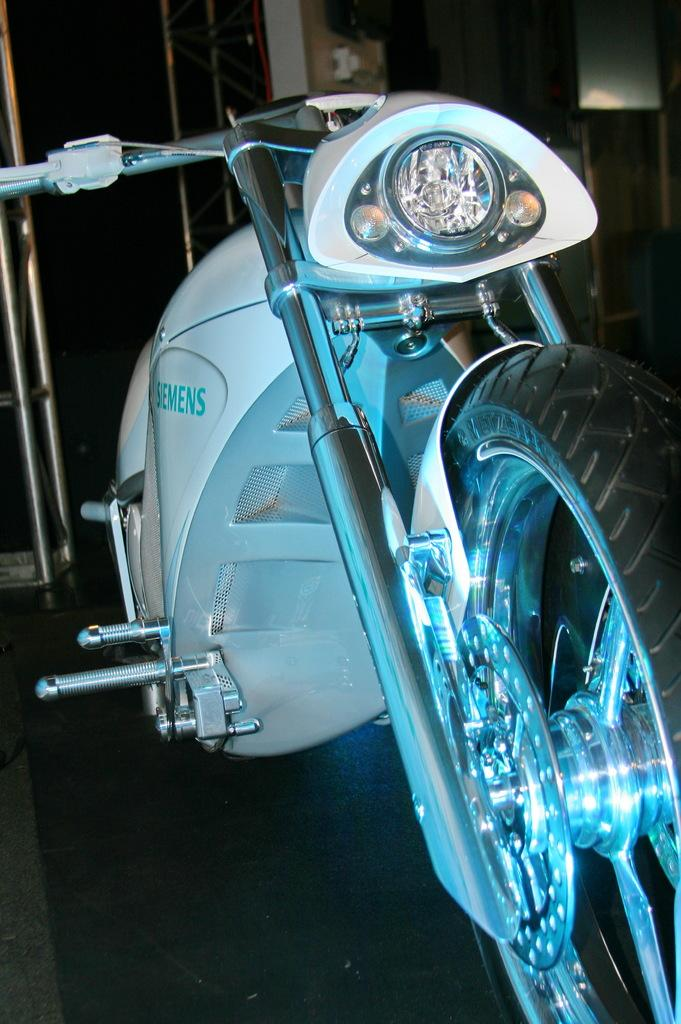What type of vehicle is partially visible in the image? The facts do not specify the type of vehicle, only that there is a part of a vehicle in the image. What can be observed about the lighting in the image? The background of the image is dark. What objects can be seen in the background of the image? There are rods visible in the background of the image. What type of art is displayed on the badge in the image? There is no badge present in the image, so it is not possible to answer a question about art displayed on it. 